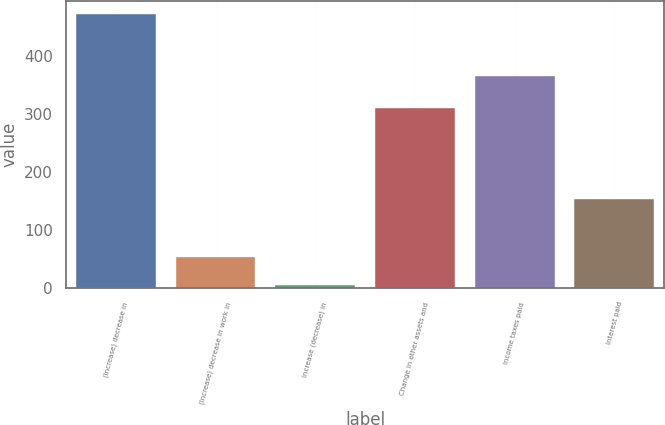Convert chart to OTSL. <chart><loc_0><loc_0><loc_500><loc_500><bar_chart><fcel>(Increase) decrease in<fcel>(Increase) decrease in work in<fcel>Increase (decrease) in<fcel>Change in other assets and<fcel>Income taxes paid<fcel>Interest paid<nl><fcel>471.4<fcel>53.2<fcel>4.5<fcel>309.39<fcel>365.4<fcel>153.9<nl></chart> 